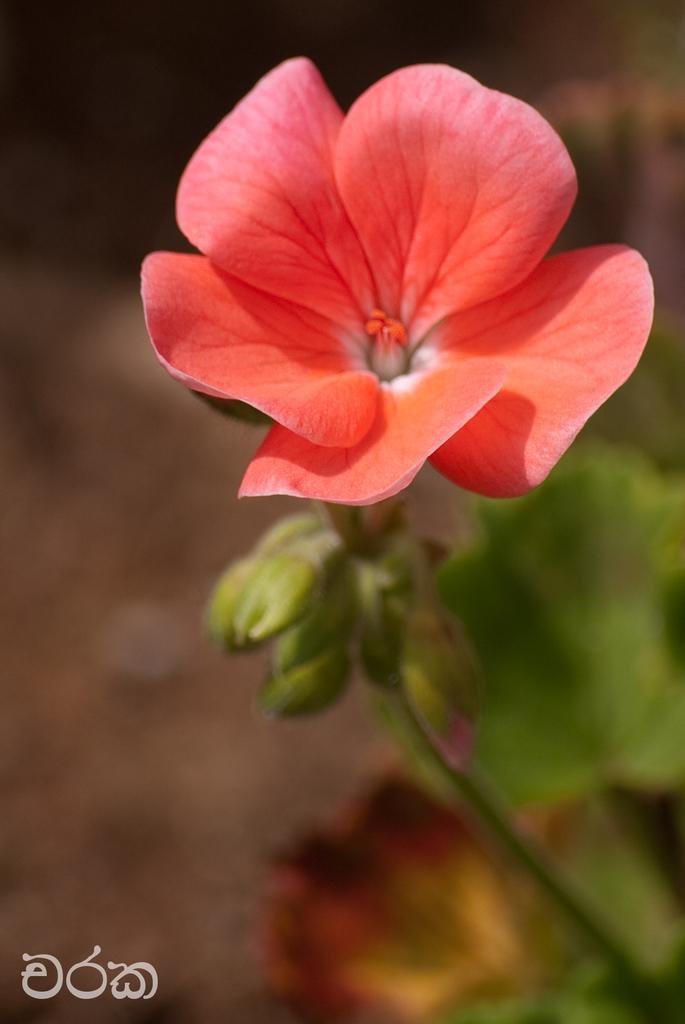Can you describe this image briefly? In this picture we can see a flower and leaves. In the bottom left corner we can see the text. In the background, the image is blurred. 